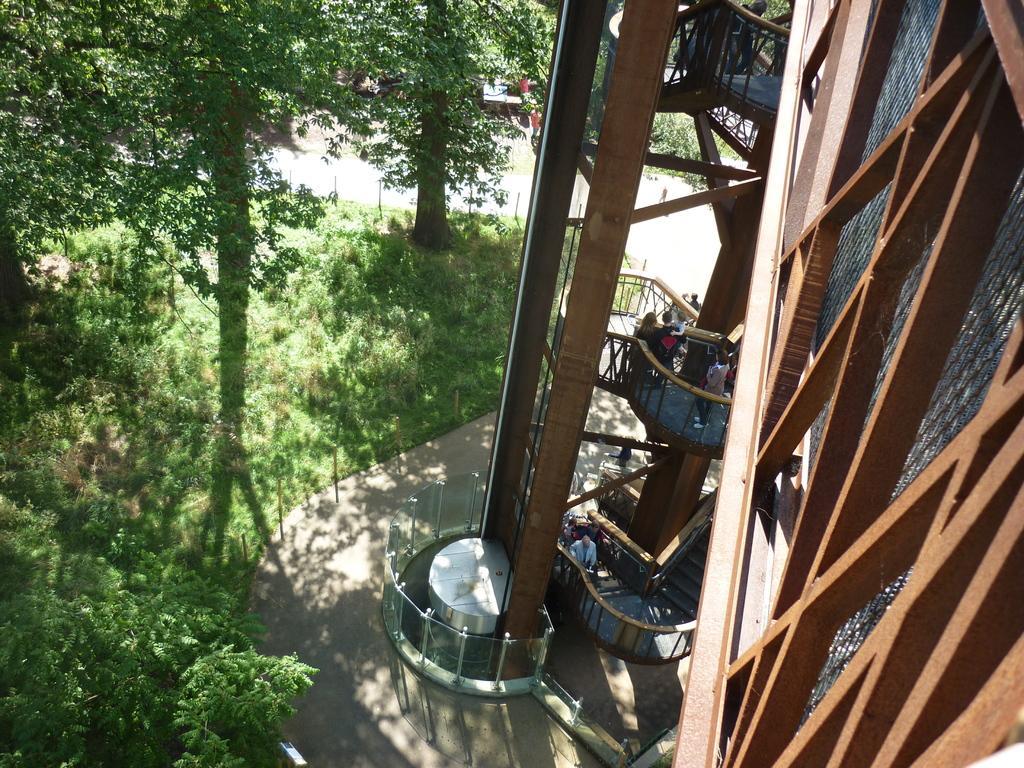Please provide a concise description of this image. In this picture we can see a few people. There is a building on the right side. We can see some plants and a few trees in the background. 